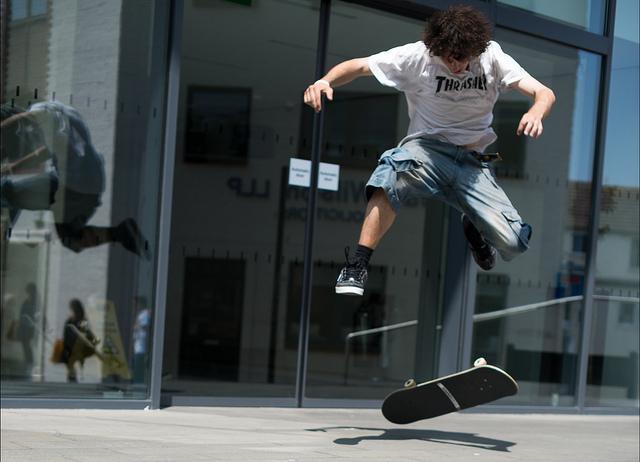How many skateboarders are in mid-air in this picture?
Give a very brief answer. 1. 